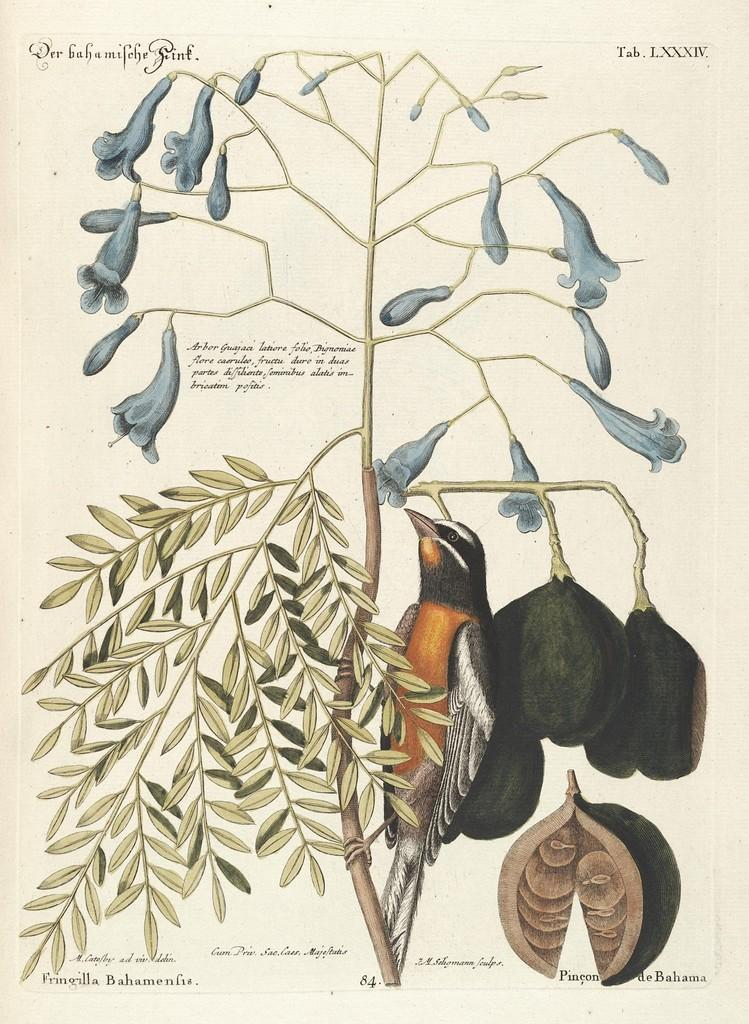What is depicted in the drawing in the image? There is a drawing of a plant in the image. What features does the plant have? The plant has flowers and fruits. What else is depicted in the drawing? There is a drawing of a bird in the image. What is written in the image? Some matter is written in the image. How much money is the bird holding in the image? There is no money present in the image, and the bird is not holding anything. 